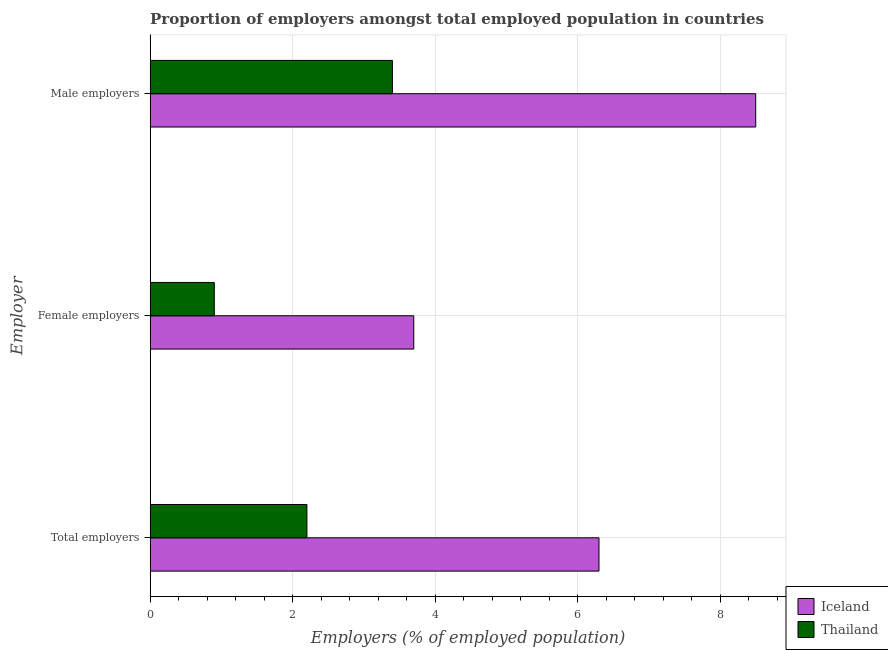How many groups of bars are there?
Make the answer very short. 3. What is the label of the 2nd group of bars from the top?
Your response must be concise. Female employers. What is the percentage of female employers in Thailand?
Ensure brevity in your answer.  0.9. Across all countries, what is the maximum percentage of male employers?
Keep it short and to the point. 8.5. Across all countries, what is the minimum percentage of male employers?
Your answer should be compact. 3.4. In which country was the percentage of male employers maximum?
Keep it short and to the point. Iceland. In which country was the percentage of total employers minimum?
Give a very brief answer. Thailand. What is the total percentage of total employers in the graph?
Provide a short and direct response. 8.5. What is the difference between the percentage of male employers in Thailand and that in Iceland?
Make the answer very short. -5.1. What is the difference between the percentage of total employers in Iceland and the percentage of male employers in Thailand?
Your response must be concise. 2.9. What is the average percentage of total employers per country?
Provide a succinct answer. 4.25. What is the difference between the percentage of total employers and percentage of female employers in Iceland?
Ensure brevity in your answer.  2.6. In how many countries, is the percentage of female employers greater than 5.2 %?
Your answer should be very brief. 0. What is the ratio of the percentage of total employers in Iceland to that in Thailand?
Provide a short and direct response. 2.86. Is the percentage of female employers in Iceland less than that in Thailand?
Your answer should be compact. No. Is the difference between the percentage of total employers in Thailand and Iceland greater than the difference between the percentage of female employers in Thailand and Iceland?
Offer a terse response. No. What is the difference between the highest and the second highest percentage of female employers?
Keep it short and to the point. 2.8. What is the difference between the highest and the lowest percentage of male employers?
Provide a short and direct response. 5.1. In how many countries, is the percentage of male employers greater than the average percentage of male employers taken over all countries?
Keep it short and to the point. 1. Is the sum of the percentage of total employers in Thailand and Iceland greater than the maximum percentage of female employers across all countries?
Provide a short and direct response. Yes. How many countries are there in the graph?
Offer a very short reply. 2. Are the values on the major ticks of X-axis written in scientific E-notation?
Give a very brief answer. No. Does the graph contain any zero values?
Offer a very short reply. No. How are the legend labels stacked?
Provide a succinct answer. Vertical. What is the title of the graph?
Make the answer very short. Proportion of employers amongst total employed population in countries. Does "Isle of Man" appear as one of the legend labels in the graph?
Provide a succinct answer. No. What is the label or title of the X-axis?
Keep it short and to the point. Employers (% of employed population). What is the label or title of the Y-axis?
Your answer should be very brief. Employer. What is the Employers (% of employed population) of Iceland in Total employers?
Make the answer very short. 6.3. What is the Employers (% of employed population) in Thailand in Total employers?
Offer a very short reply. 2.2. What is the Employers (% of employed population) in Iceland in Female employers?
Offer a very short reply. 3.7. What is the Employers (% of employed population) in Thailand in Female employers?
Ensure brevity in your answer.  0.9. What is the Employers (% of employed population) in Iceland in Male employers?
Offer a terse response. 8.5. What is the Employers (% of employed population) in Thailand in Male employers?
Ensure brevity in your answer.  3.4. Across all Employer, what is the maximum Employers (% of employed population) of Iceland?
Offer a very short reply. 8.5. Across all Employer, what is the maximum Employers (% of employed population) in Thailand?
Give a very brief answer. 3.4. Across all Employer, what is the minimum Employers (% of employed population) in Iceland?
Offer a very short reply. 3.7. Across all Employer, what is the minimum Employers (% of employed population) in Thailand?
Ensure brevity in your answer.  0.9. What is the difference between the Employers (% of employed population) of Iceland in Total employers and that in Female employers?
Your response must be concise. 2.6. What is the difference between the Employers (% of employed population) of Thailand in Total employers and that in Male employers?
Offer a terse response. -1.2. What is the difference between the Employers (% of employed population) in Thailand in Female employers and that in Male employers?
Your answer should be compact. -2.5. What is the difference between the Employers (% of employed population) of Iceland in Total employers and the Employers (% of employed population) of Thailand in Male employers?
Keep it short and to the point. 2.9. What is the difference between the Employers (% of employed population) of Iceland in Female employers and the Employers (% of employed population) of Thailand in Male employers?
Offer a terse response. 0.3. What is the average Employers (% of employed population) of Iceland per Employer?
Ensure brevity in your answer.  6.17. What is the average Employers (% of employed population) in Thailand per Employer?
Give a very brief answer. 2.17. What is the difference between the Employers (% of employed population) of Iceland and Employers (% of employed population) of Thailand in Female employers?
Provide a short and direct response. 2.8. What is the difference between the Employers (% of employed population) in Iceland and Employers (% of employed population) in Thailand in Male employers?
Provide a short and direct response. 5.1. What is the ratio of the Employers (% of employed population) in Iceland in Total employers to that in Female employers?
Your response must be concise. 1.7. What is the ratio of the Employers (% of employed population) of Thailand in Total employers to that in Female employers?
Keep it short and to the point. 2.44. What is the ratio of the Employers (% of employed population) in Iceland in Total employers to that in Male employers?
Make the answer very short. 0.74. What is the ratio of the Employers (% of employed population) in Thailand in Total employers to that in Male employers?
Offer a very short reply. 0.65. What is the ratio of the Employers (% of employed population) of Iceland in Female employers to that in Male employers?
Ensure brevity in your answer.  0.44. What is the ratio of the Employers (% of employed population) of Thailand in Female employers to that in Male employers?
Offer a terse response. 0.26. What is the difference between the highest and the second highest Employers (% of employed population) in Iceland?
Make the answer very short. 2.2. What is the difference between the highest and the second highest Employers (% of employed population) in Thailand?
Make the answer very short. 1.2. What is the difference between the highest and the lowest Employers (% of employed population) of Iceland?
Your answer should be compact. 4.8. What is the difference between the highest and the lowest Employers (% of employed population) of Thailand?
Make the answer very short. 2.5. 